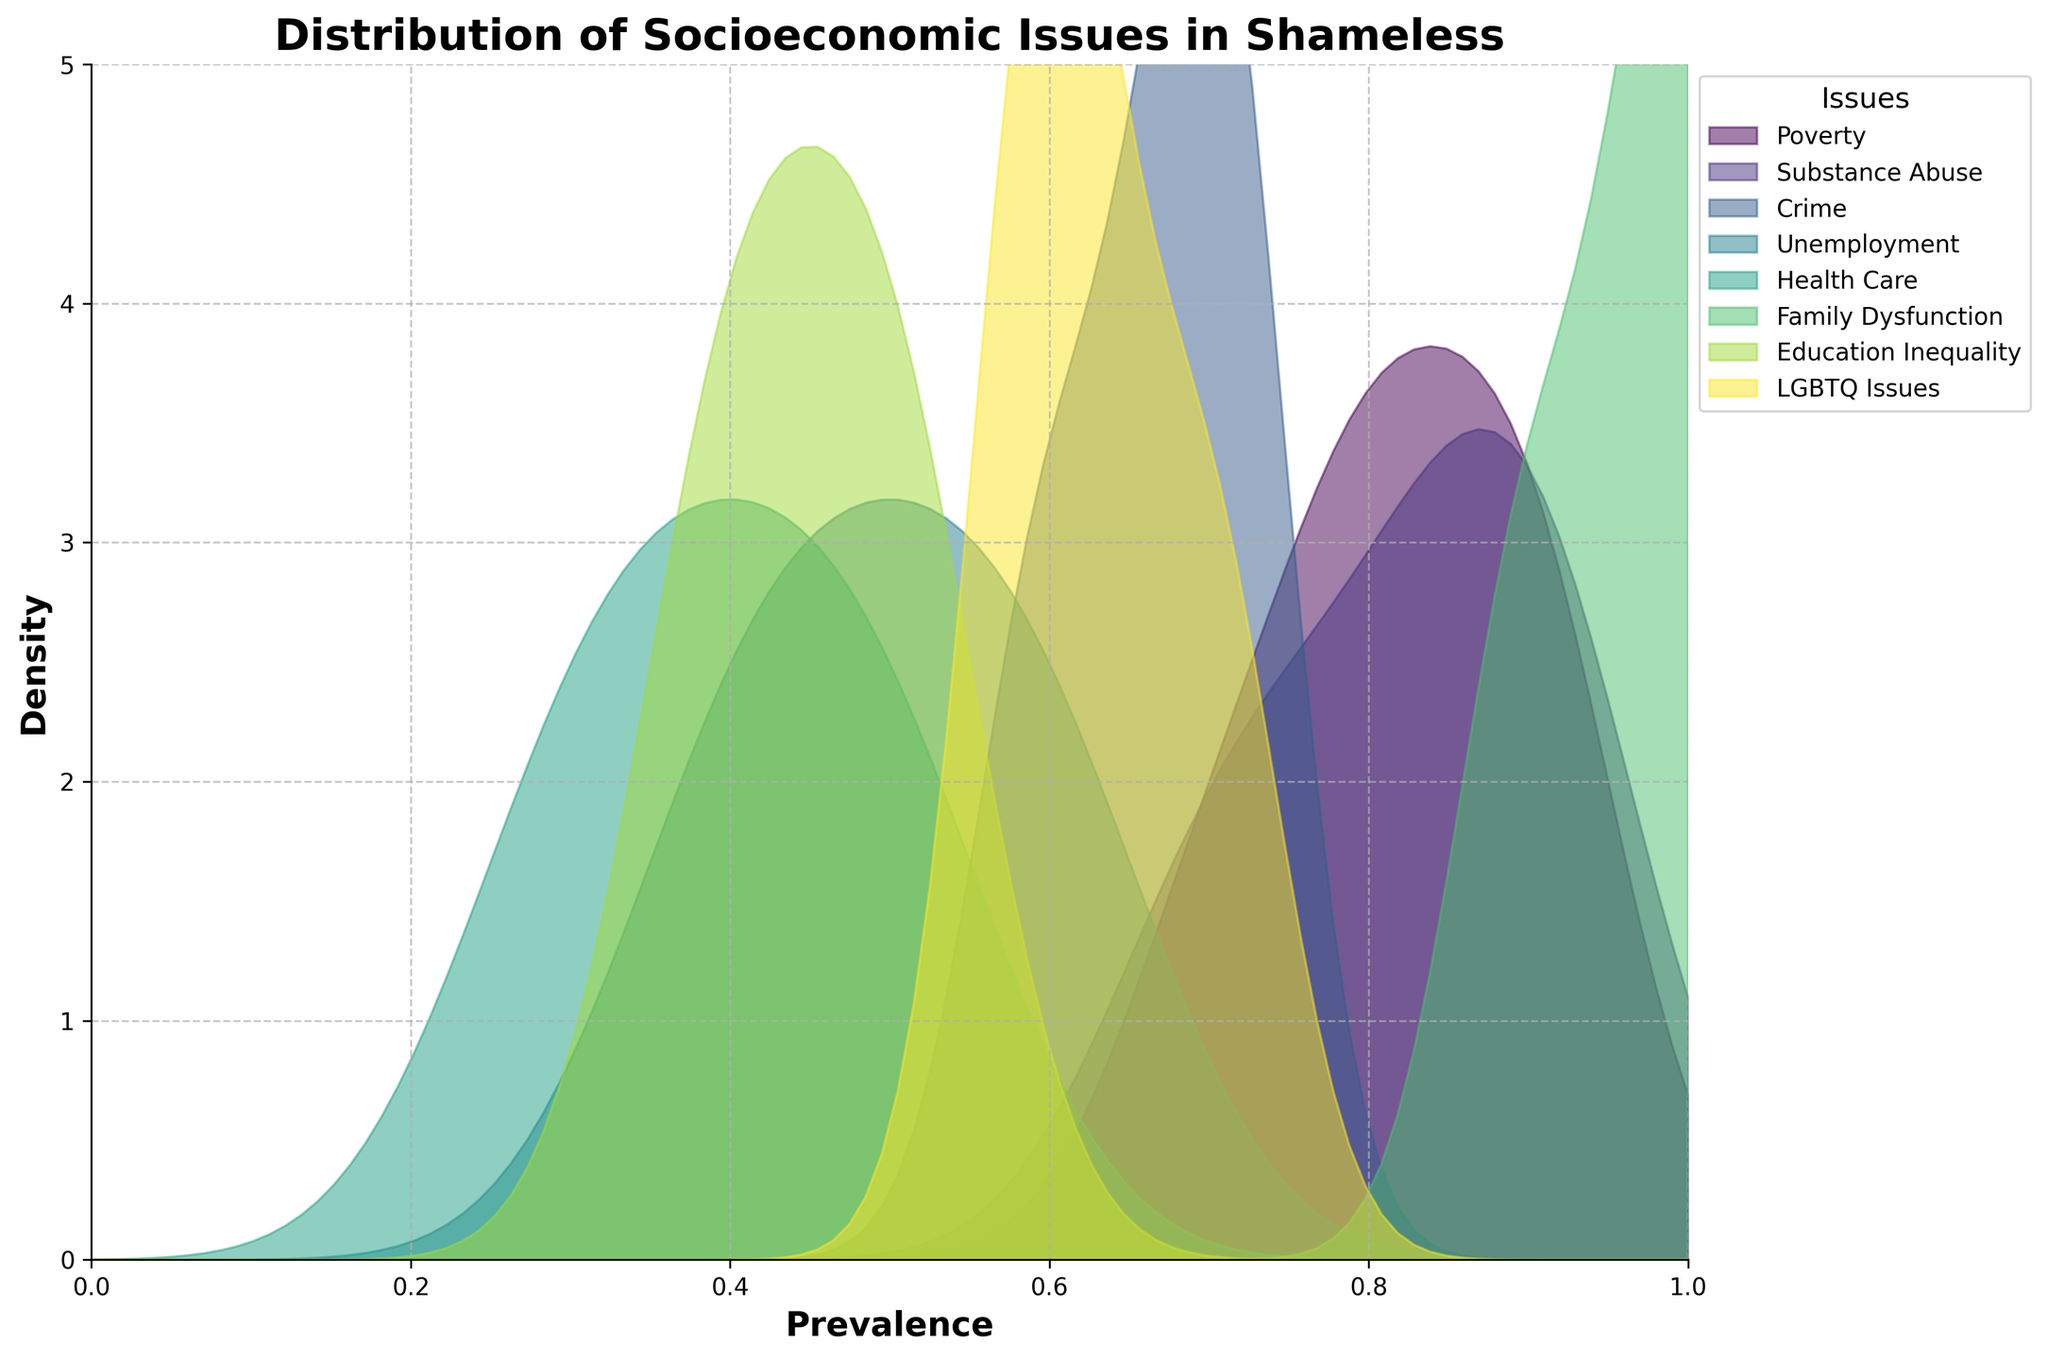What is the title of the figure? The title of the figure is displayed at the top of the plot and provides an overview of what the plot represents.
Answer: Distribution of Socioeconomic Issues in Shameless What is the most prevalent issue addressed in "Shameless"? Identify which density plot has the highest peak on the y-axis. A higher peak indicates a high prevalence of that issue.
Answer: Family Dysfunction Which issue has the broadest range of prevalence in the episodes? Look at which density plot extends the farthest along the x-axis, which ranges from 0 to 1.
Answer: Poverty How does the prevalence of Substance Abuse compare to that of LGBTQ Issues? Compare the peaks and ranges of the density plots for Substance Abuse and LGBTQ Issues. Notice the general height and spread.
Answer: Substance Abuse generally has higher prevalence Which issue has the most concentrated prevalence around 0.7? Identify the issue whose density plot has the highest peak near the prevalence value of 0.7 on the x-axis.
Answer: Poverty What is the issue with the least density in the middle prevalence range (0.3 to 0.6)? Look for the density plot that has the least height between the prevalence values of 0.3 and 0.6 along the x-axis.
Answer: Health Care Are there any issues with a maximum density peak greater than 4? Examine the y-axis and identify any density plots that peak above the value of 4.
Answer: No Which issue exhibits the most variability in its prevalence? Look for the density plot that is the widest and not concentrated around a single prevalence value.
Answer: Poverty Is the prevalence of Crime higher than that of Education Inequality at any point? Compare the density plots of Crime and Education Inequality to see if the Crime plot is above the Education Inequality plot at any x-axis value.
Answer: Yes What differences can be seen between the issues of Family Dysfunction and Unemployment in terms of prevalence? Compare the shapes and height of the density plots. Family Dysfunction has a high narrow peak, indicating very high prevalence in some episodes, whereas Unemployment is lower and spreads out more.
Answer: Family Dysfunction is more concentrated and prevalent 